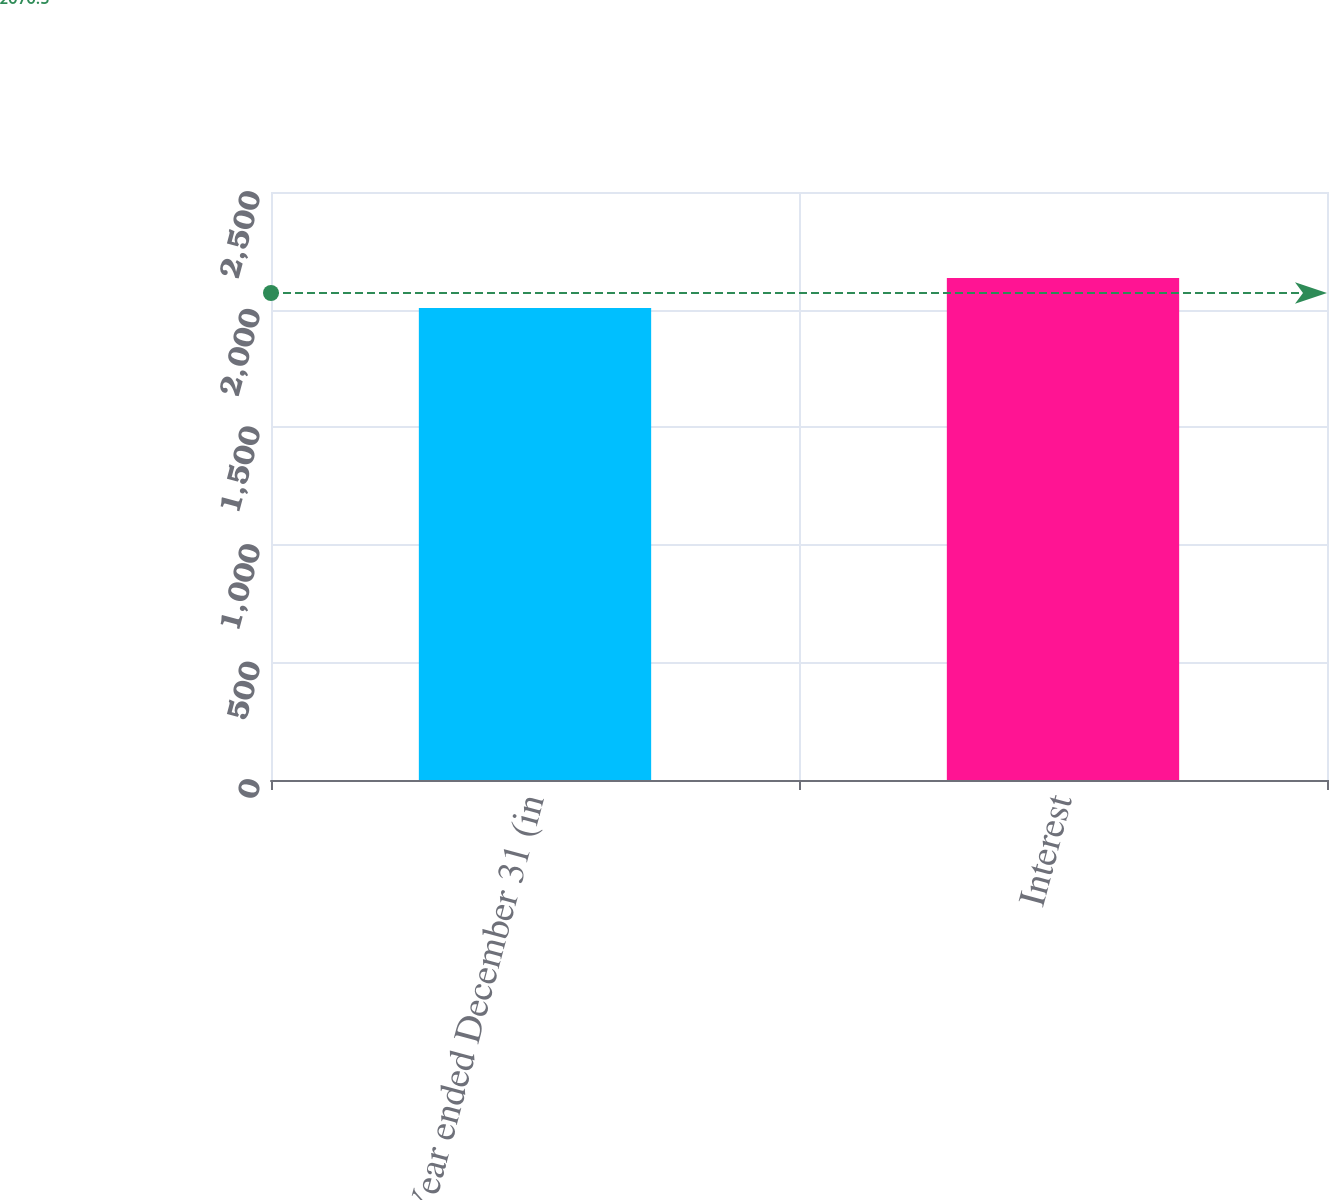Convert chart to OTSL. <chart><loc_0><loc_0><loc_500><loc_500><bar_chart><fcel>Year ended December 31 (in<fcel>Interest<nl><fcel>2007<fcel>2134<nl></chart> 